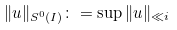<formula> <loc_0><loc_0><loc_500><loc_500>\| u \| _ { S ^ { 0 } ( I ) } \colon = \sup \| u \| _ { \ll i }</formula> 